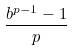<formula> <loc_0><loc_0><loc_500><loc_500>\frac { b ^ { p - 1 } - 1 } { p }</formula> 